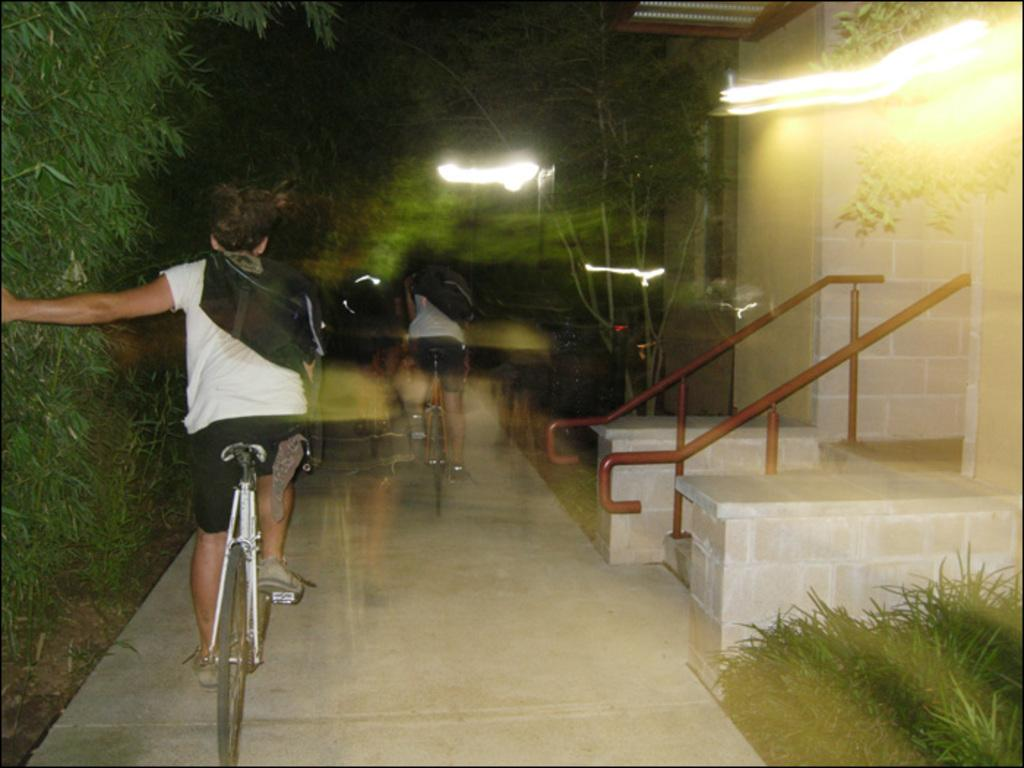What is the person in the image doing? There is a person riding a bicycle in the image. What can be seen near the person riding the bicycle? Railing is visible in the image. What type of terrain is present in the image? Grass is present in the image. What can be seen providing illumination in the image? There are lights in the image. What type of vegetation is visible in the image? Trees are visible in the image. What type of owl can be seen wearing a skirt in the image? There is no owl or skirt present in the image. What scent can be detected from the image? The image does not provide any information about scents, as it is a visual medium. 